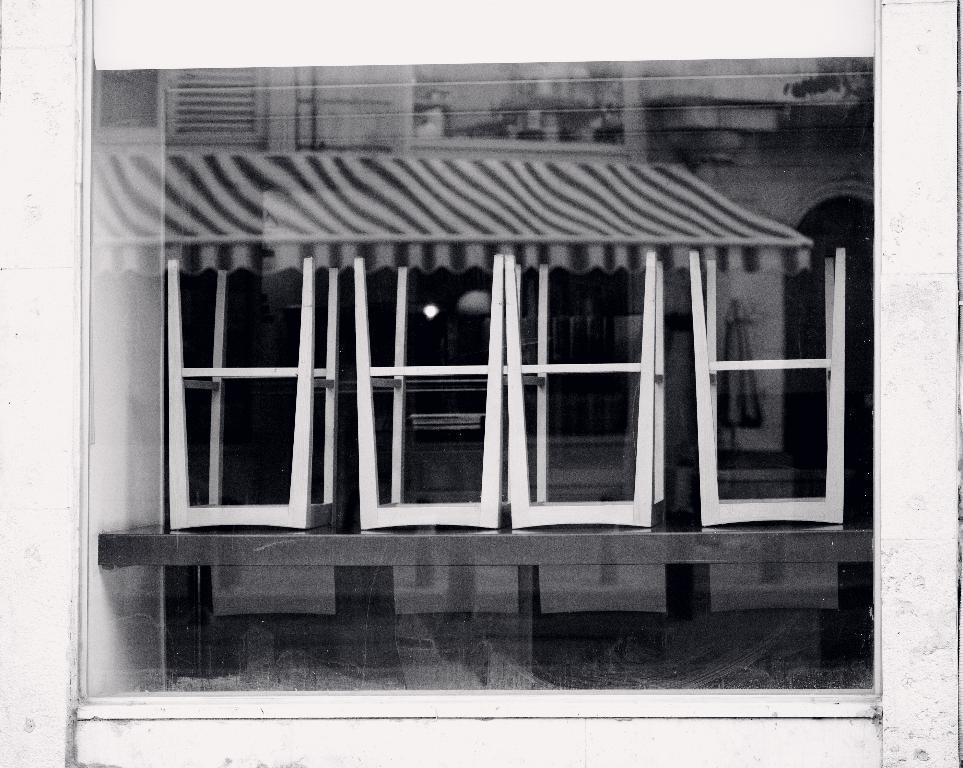Please provide a concise description of this image. In this image in the center there is a window, and in the window we could see a reflection of table, chairs and a wall and tent. 